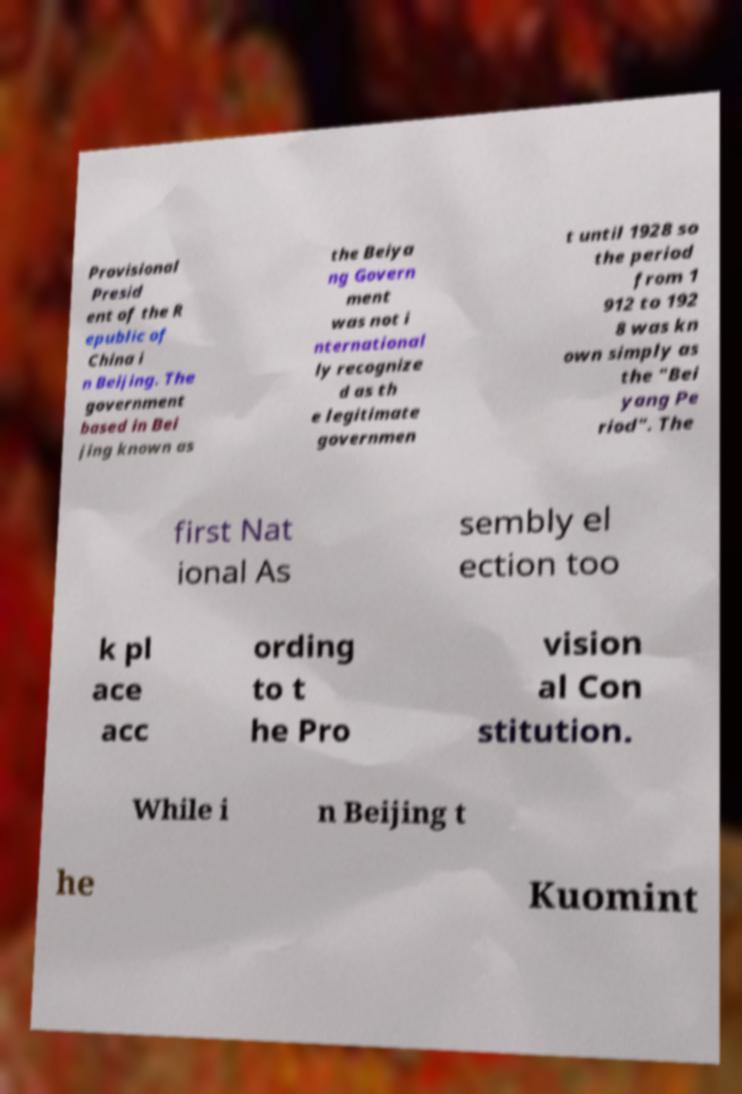What messages or text are displayed in this image? I need them in a readable, typed format. Provisional Presid ent of the R epublic of China i n Beijing. The government based in Bei jing known as the Beiya ng Govern ment was not i nternational ly recognize d as th e legitimate governmen t until 1928 so the period from 1 912 to 192 8 was kn own simply as the "Bei yang Pe riod". The first Nat ional As sembly el ection too k pl ace acc ording to t he Pro vision al Con stitution. While i n Beijing t he Kuomint 